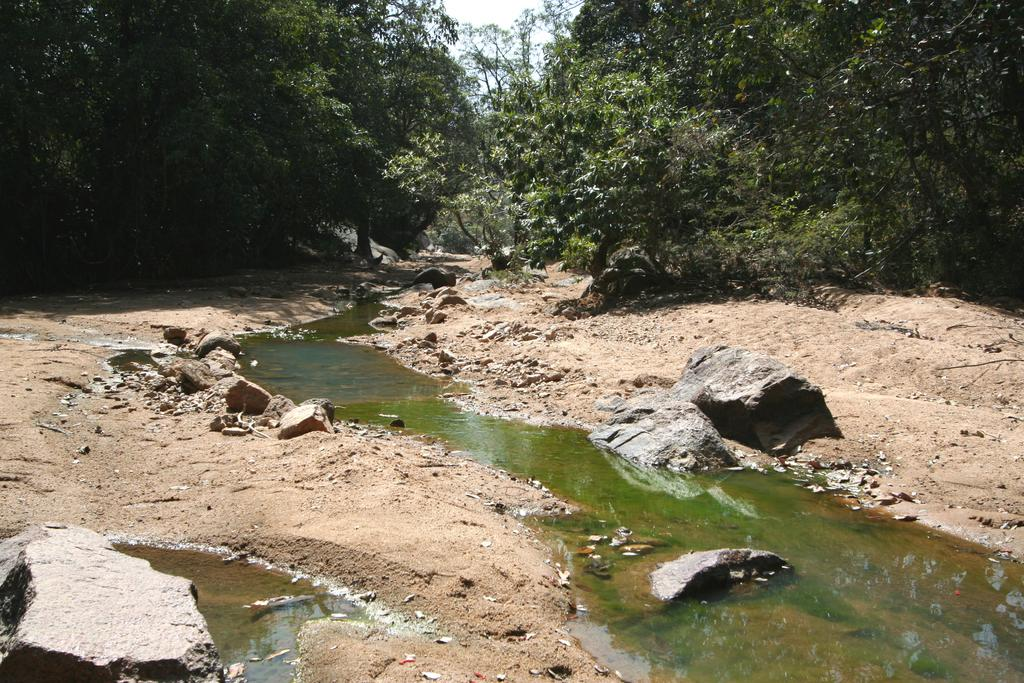What is one of the main elements in the image? There is water in the image. What other natural elements can be seen in the image? There are stones, trees, and rocks in the image. What can be seen in the background of the image? The sky is visible in the background of the image. What type of pen is being used to draw on the rocks in the image? There is no pen or drawing activity present in the image; it features natural elements such as water, stones, trees, and rocks. 